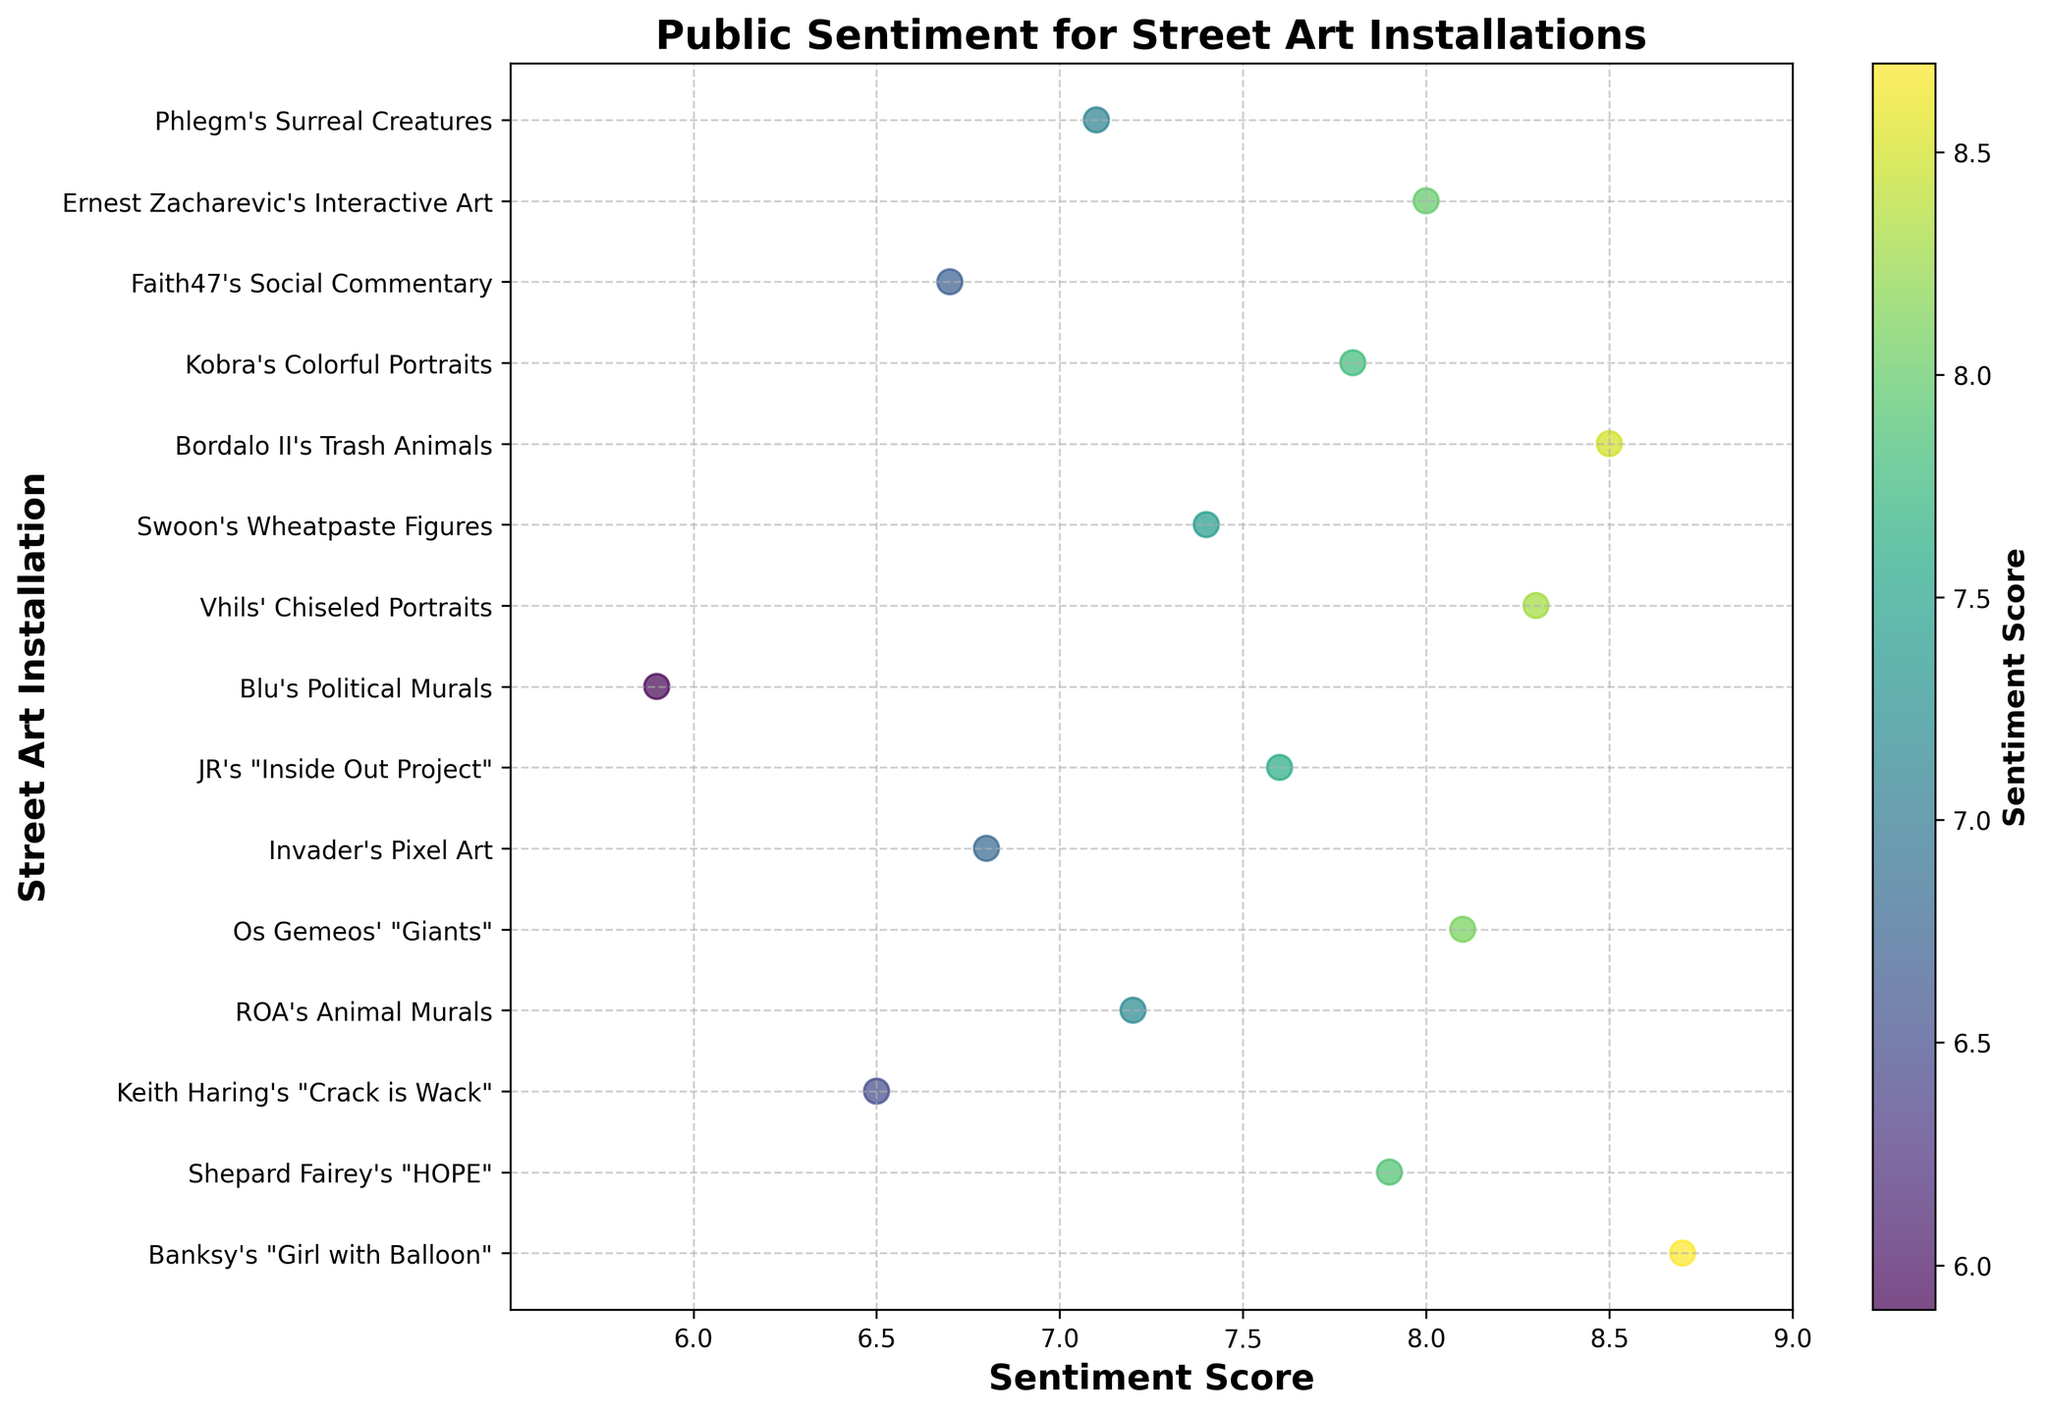what is the title of the figure? The title of the figure is displayed prominently at the top of the plot. It usually provides an overview of what the figure is about. In this case, it is "Public Sentiment for Street Art Installations".
Answer: Public Sentiment for Street Art Installations How many street art installations are illustrated in the plot? Each unique installation name on the y-axis corresponds to a street art installation. By counting these labels, we can determine the total number. There are 15 installations listed in the data.
Answer: 15 Which art installation has the highest sentiment score? By observing the x-axis values and looking for the furthest data point to the right, we can identify which installation has the highest sentiment score. In this case, "Banksy's 'Girl with Balloon'" has the highest score of 8.7.
Answer: Banksy's "Girl with Balloon" What is the range of sentiment scores displayed in the plot? The range can be determined by finding the difference between the highest and the lowest sentiment scores represented in the plot. The highest score is 8.7, and the lowest is 5.9, so the range is 8.7 - 5.9 = 2.8.
Answer: 2.8 What is the average sentiment score of all street art installations? To find the average, sum all the sentiment scores and divide by the number of installations. The sum is 7.9 + 8.7 + 6.5 + 7.2 + 8.1 + 6.8 + 7.6 + 5.9 + 8.3 + 7.4 + 8.5 + 7.8 + 6.7 + 8.0 + 7.1 = 108.5. Divide this by 15 installations to get the average score of 108.5/15 = 7.233.
Answer: 7.233 Which two art installations have the most similar sentiment scores? By visually scanning the plot for points that are closest together on the x-axis, we can identify which sentiment scores are most similar. "Shepard Fairey's 'HOPE'" with a score of 7.9 and "Ernest Zacharevic's Interactive Art" with a score of 8.0 are the closest.
Answer: Shepard Fairey's "HOPE" and Ernest Zacharevic's Interactive Art How many installations have a sentiment score above 8? By counting the data points that appear to the right of the 8.0 mark on the x-axis, we determine the number of installations with sentiment scores above 8. There are 7 such installations.
Answer: 7 Which installation has the lowest sentiment score and what is that score? The lowest score can be found by identifying the point furthest left on the x-axis. "Blu's Political Murals" has the lowest score of 5.9.
Answer: Blu's Political Murals, 5.9 How does the sentiment score of "Bordalo II's Trash Animals" compare to "Os Gemeos' 'Giants'"? By comparing their exact sentiment scores on the x-axis, "Bordalo II's Trash Animals" has a score of 8.5 and "Os Gemeos' 'Giants'" has a score of 8.1. Thus, Bordalo II's installation has a higher sentiment score than Os Gemeos'.
Answer: Bordalo II's Trash Animals has a higher score than Os Gemeos' "Giants" Which installation has a sentiment score closest to the median score of all installations? First, we need to determine the median sentiment score by arranging all scores in ascending order and identifying the middle value. The sorted scores are: 5.9, 6.5, 6.7, 6.8, 7.1, 7.2, 7.4, 7.6, 7.8, 7.9, 8.0, 8.1, 8.3, 8.5, 8.7. The median score is the 8th value, 7.6. "JR's 'Inside Out Project'" matches this exact median score.
Answer: JR's "Inside Out Project" 